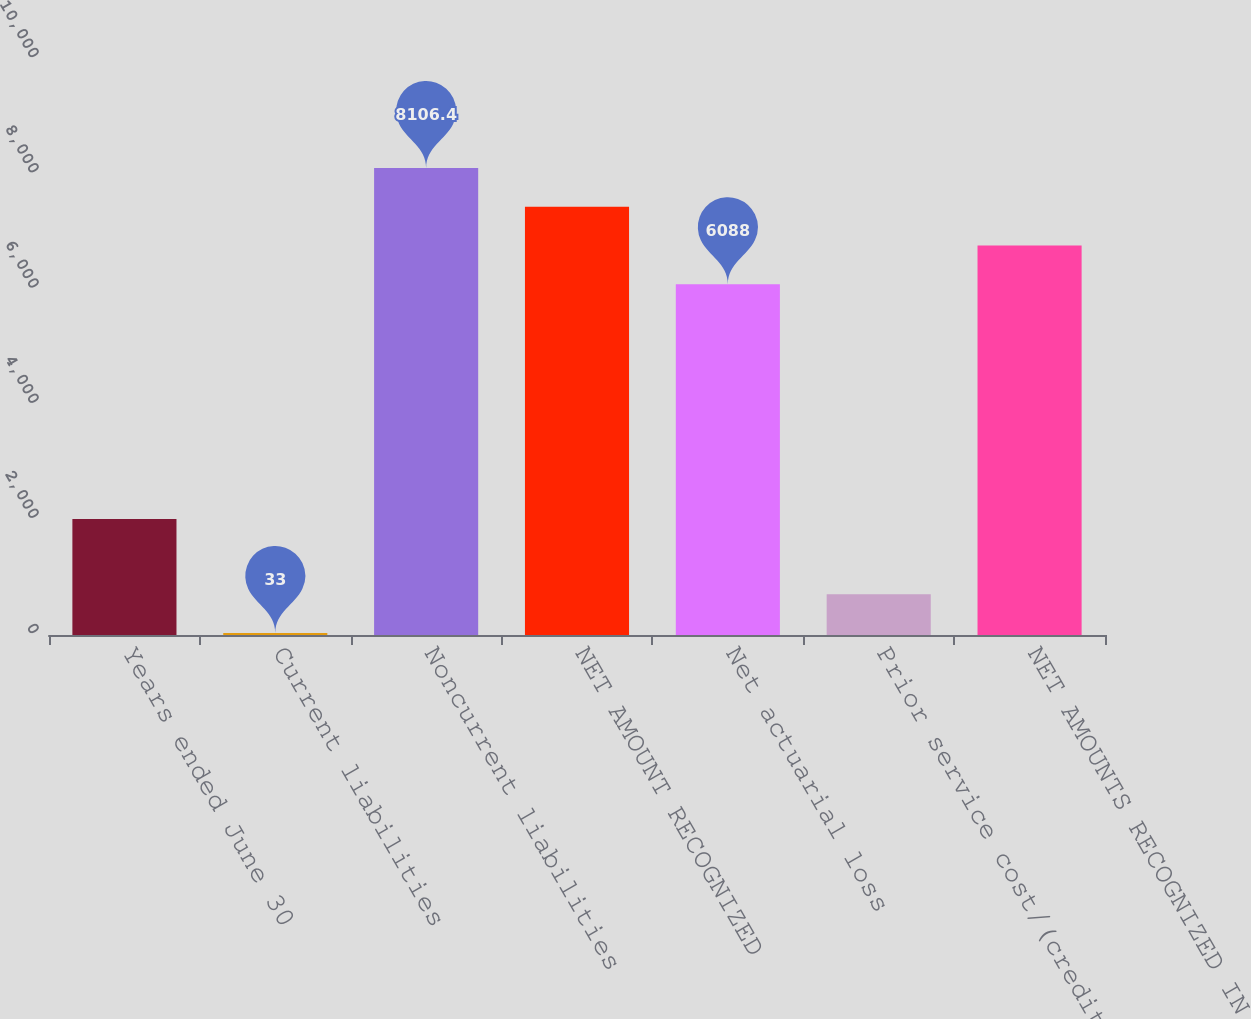Convert chart to OTSL. <chart><loc_0><loc_0><loc_500><loc_500><bar_chart><fcel>Years ended June 30<fcel>Current liabilities<fcel>Noncurrent liabilities<fcel>NET AMOUNT RECOGNIZED<fcel>Net actuarial loss<fcel>Prior service cost/(credit)<fcel>NET AMOUNTS RECOGNIZED IN AOCI<nl><fcel>2016<fcel>33<fcel>8106.4<fcel>7433.6<fcel>6088<fcel>705.8<fcel>6760.8<nl></chart> 